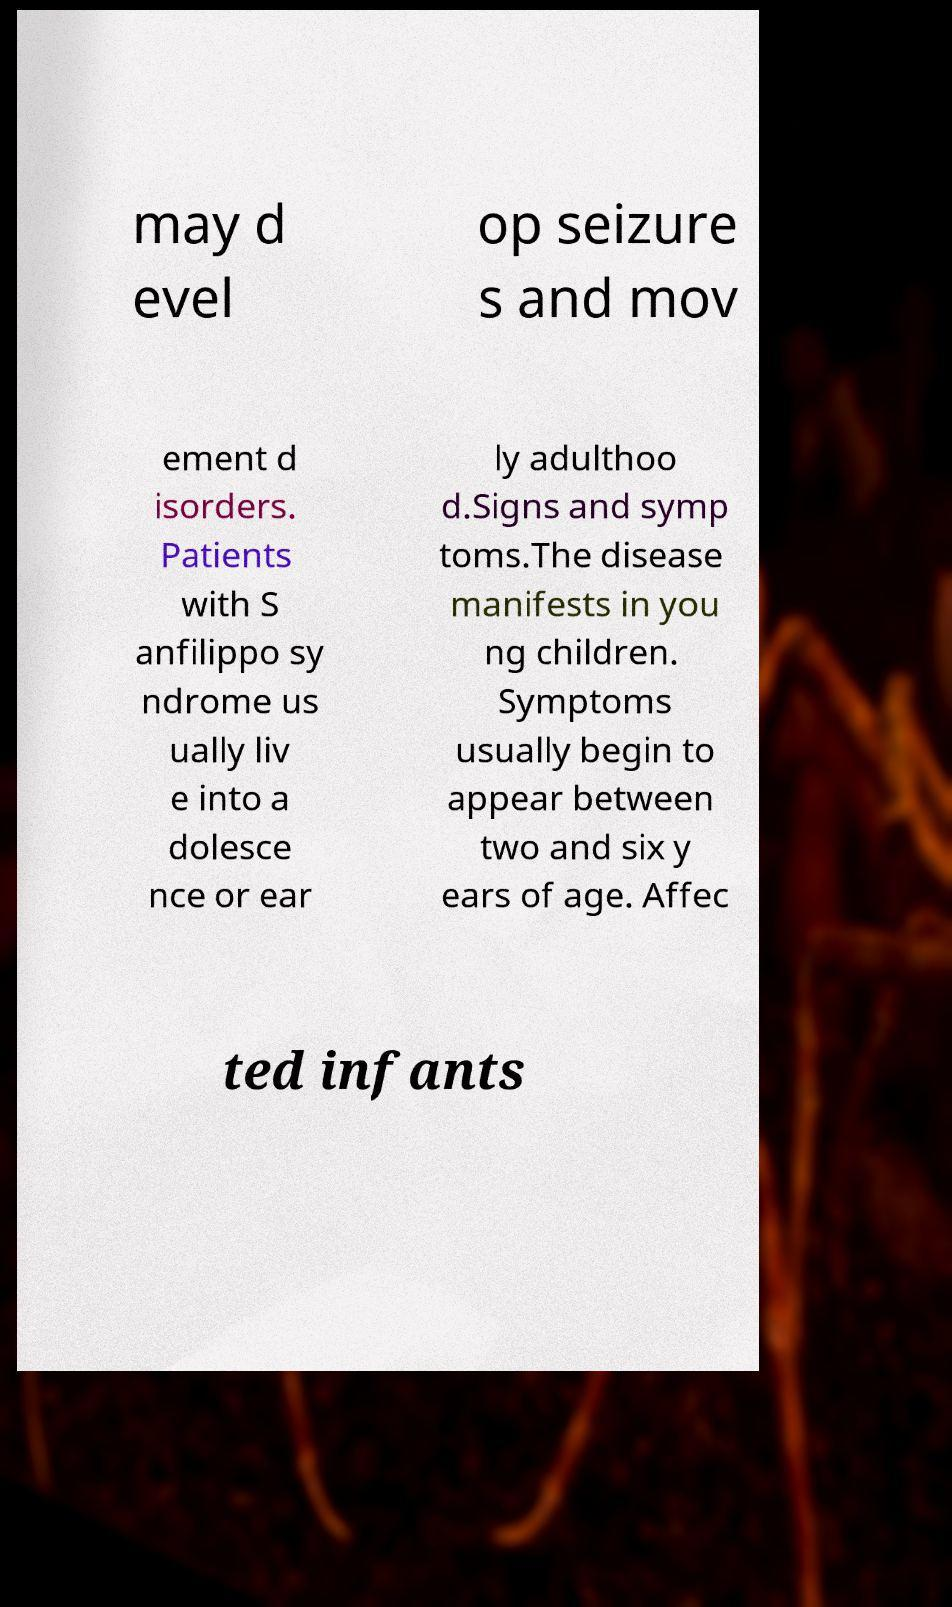Please read and relay the text visible in this image. What does it say? may d evel op seizure s and mov ement d isorders. Patients with S anfilippo sy ndrome us ually liv e into a dolesce nce or ear ly adulthoo d.Signs and symp toms.The disease manifests in you ng children. Symptoms usually begin to appear between two and six y ears of age. Affec ted infants 